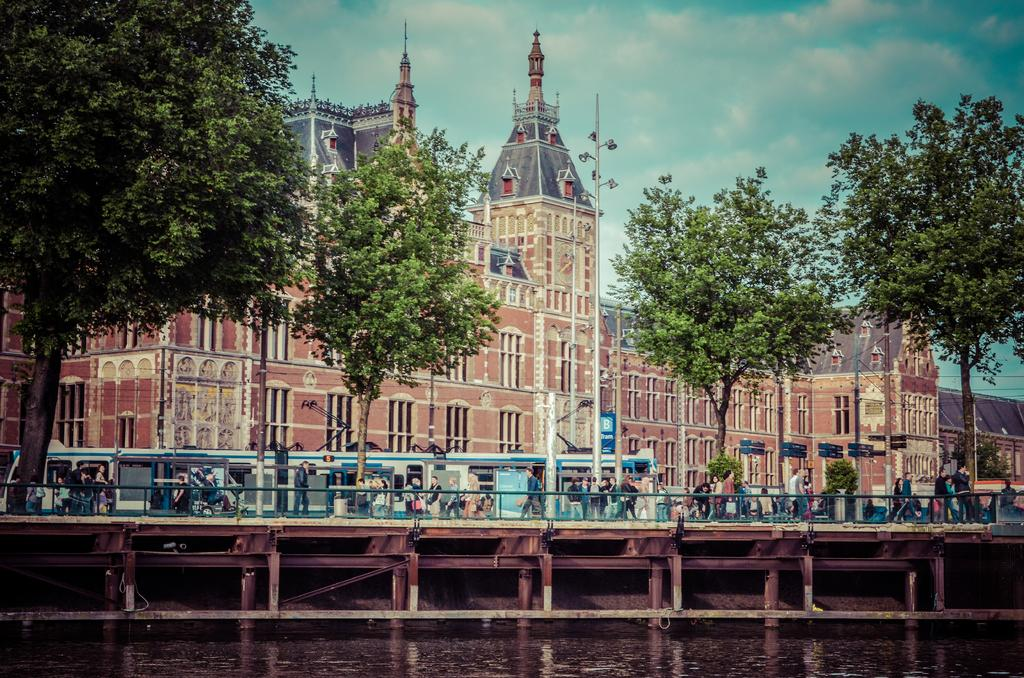What are the people in the image doing? There are persons walking in the center of the image. What type of natural elements can be seen in the image? There are trees in the image. What is behind the persons walking in the image? There are vehicles behind the persons. What type of structures can be seen in the background of the image? There are buildings in the background of the image. How would you describe the weather based on the image? The sky is cloudy in the image. What is the price of the horse in the image? There is no horse present in the image, so it is not possible to determine its price. 